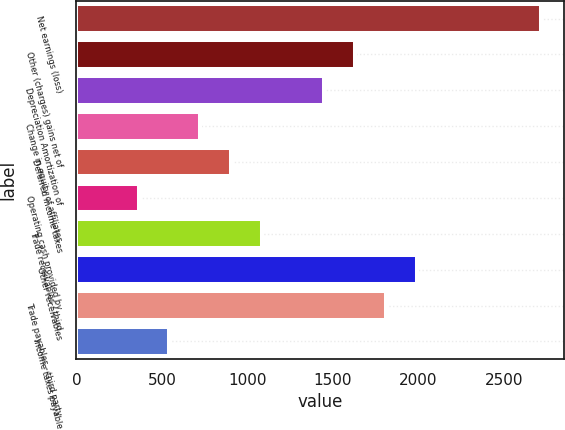<chart> <loc_0><loc_0><loc_500><loc_500><bar_chart><fcel>Net earnings (loss)<fcel>Other (charges) gains net of<fcel>Depreciation Amortization of<fcel>Change in equity of affiliates<fcel>Deferred income taxes<fcel>Operating cash provided by<fcel>Trade receivables - third<fcel>Other receivables<fcel>Trade payables - third party<fcel>Income taxes payable<nl><fcel>2716<fcel>1630<fcel>1449<fcel>725<fcel>906<fcel>363<fcel>1087<fcel>1992<fcel>1811<fcel>544<nl></chart> 